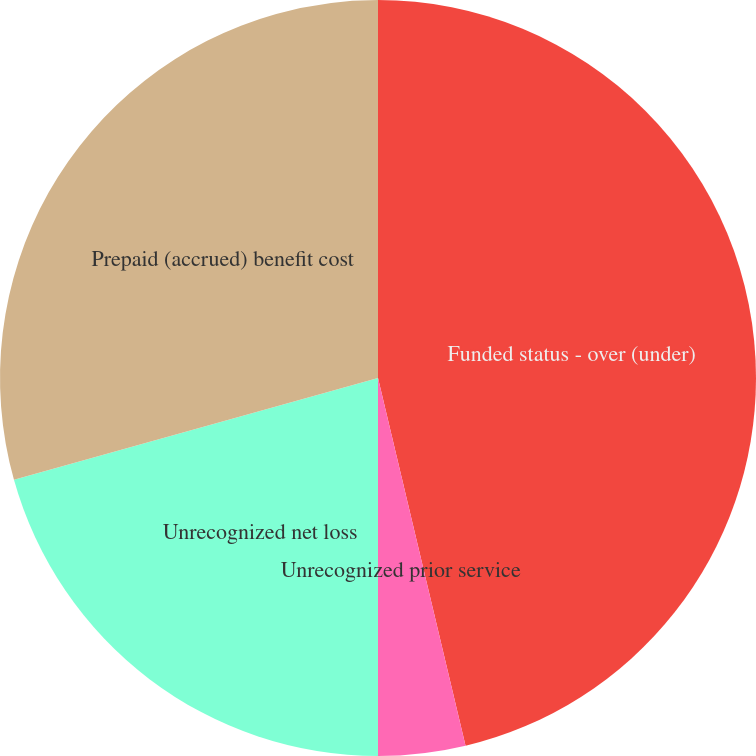Convert chart. <chart><loc_0><loc_0><loc_500><loc_500><pie_chart><fcel>Funded status - over (under)<fcel>Unrecognized prior service<fcel>Unrecognized net loss<fcel>Prepaid (accrued) benefit cost<nl><fcel>46.28%<fcel>3.72%<fcel>20.66%<fcel>29.34%<nl></chart> 